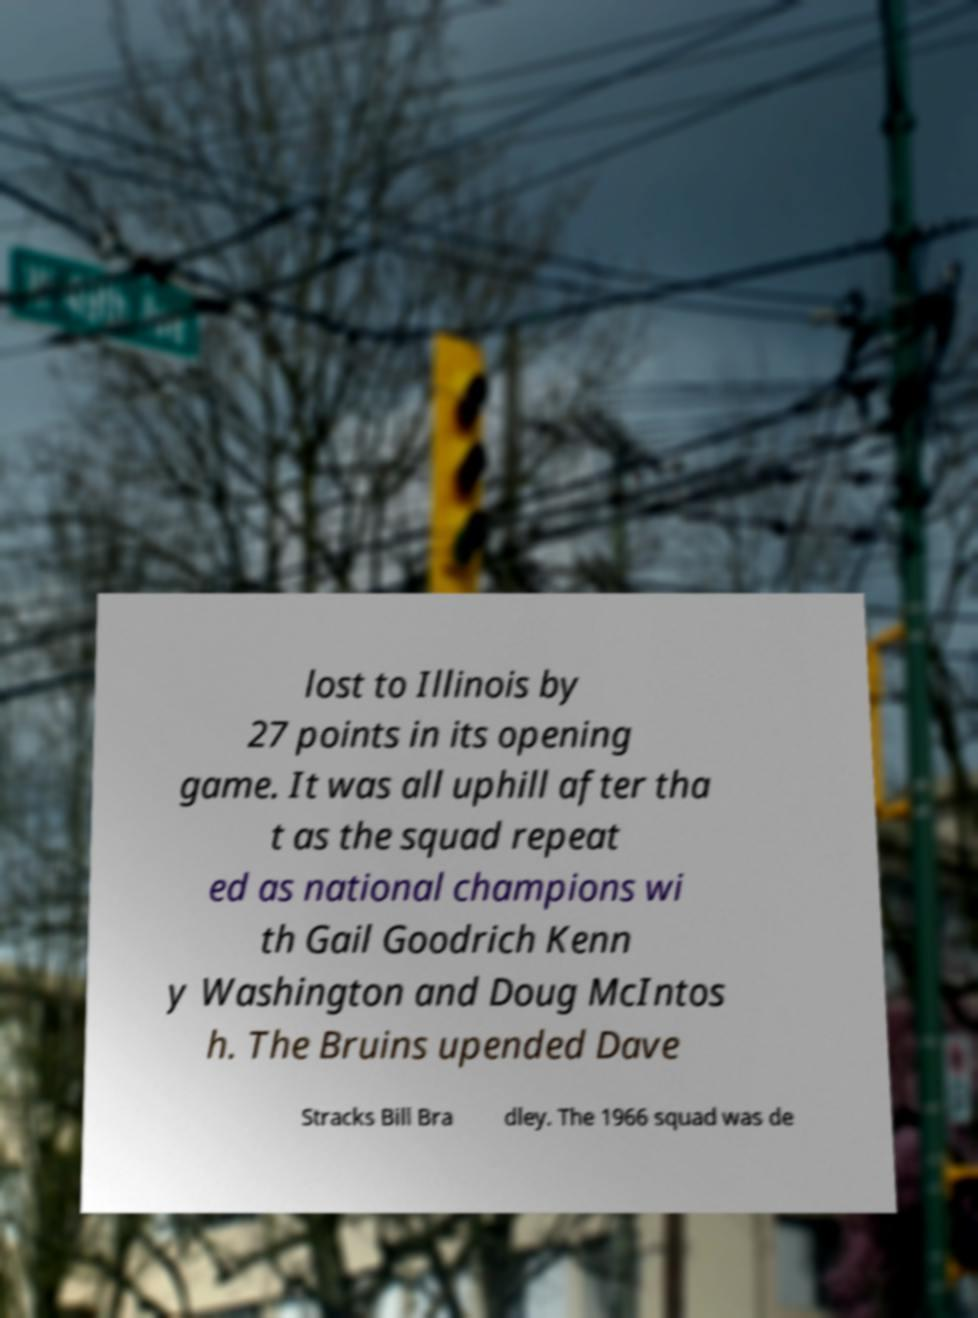For documentation purposes, I need the text within this image transcribed. Could you provide that? lost to Illinois by 27 points in its opening game. It was all uphill after tha t as the squad repeat ed as national champions wi th Gail Goodrich Kenn y Washington and Doug McIntos h. The Bruins upended Dave Stracks Bill Bra dley. The 1966 squad was de 